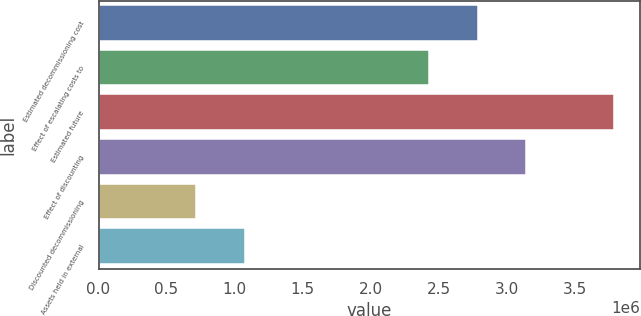Convert chart to OTSL. <chart><loc_0><loc_0><loc_500><loc_500><bar_chart><fcel>Estimated decommissioning cost<fcel>Effect of escalating costs to<fcel>Estimated future<fcel>Effect of discounting<fcel>Discounted decommissioning<fcel>Assets held in external<nl><fcel>2.78714e+06<fcel>2.4303e+06<fcel>3.79336e+06<fcel>3.14399e+06<fcel>719770<fcel>1.07661e+06<nl></chart> 